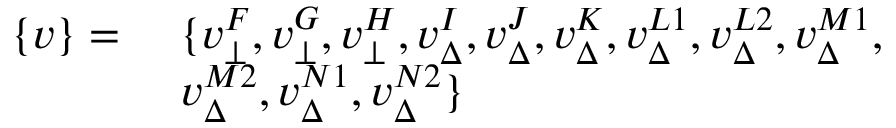<formula> <loc_0><loc_0><loc_500><loc_500>\begin{array} { r l } { \{ v \} = } & { \ \{ v _ { \bot } ^ { F } , v _ { \bot } ^ { G } , v _ { \bot } ^ { H } , v _ { \Delta } ^ { I } , v _ { \Delta } ^ { J } , v _ { \Delta } ^ { K } , v _ { \Delta } ^ { L 1 } , v _ { \Delta } ^ { L 2 } , v _ { \Delta } ^ { M 1 } , } \\ & { \ v _ { \Delta } ^ { M 2 } , v _ { \Delta } ^ { N 1 } , v _ { \Delta } ^ { N 2 } \} } \end{array}</formula> 